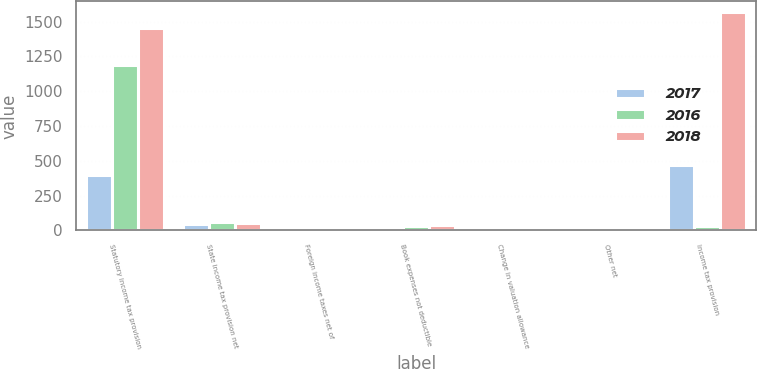Convert chart to OTSL. <chart><loc_0><loc_0><loc_500><loc_500><stacked_bar_chart><ecel><fcel>Statutory income tax provision<fcel>State income tax provision net<fcel>Foreign income taxes net of<fcel>Book expenses not deductible<fcel>Change in valuation allowance<fcel>Other net<fcel>Income tax provision<nl><fcel>2017<fcel>396<fcel>44<fcel>23<fcel>12<fcel>6<fcel>3<fcel>472<nl><fcel>2016<fcel>1188<fcel>59<fcel>7<fcel>33<fcel>3<fcel>5<fcel>28<nl><fcel>2018<fcel>1453<fcel>56<fcel>6<fcel>35<fcel>7<fcel>10<fcel>1568<nl></chart> 